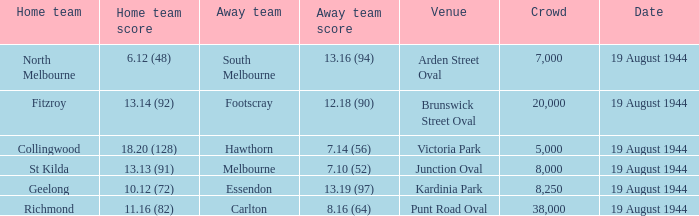What is Fitzroy's Home team score? 13.14 (92). 